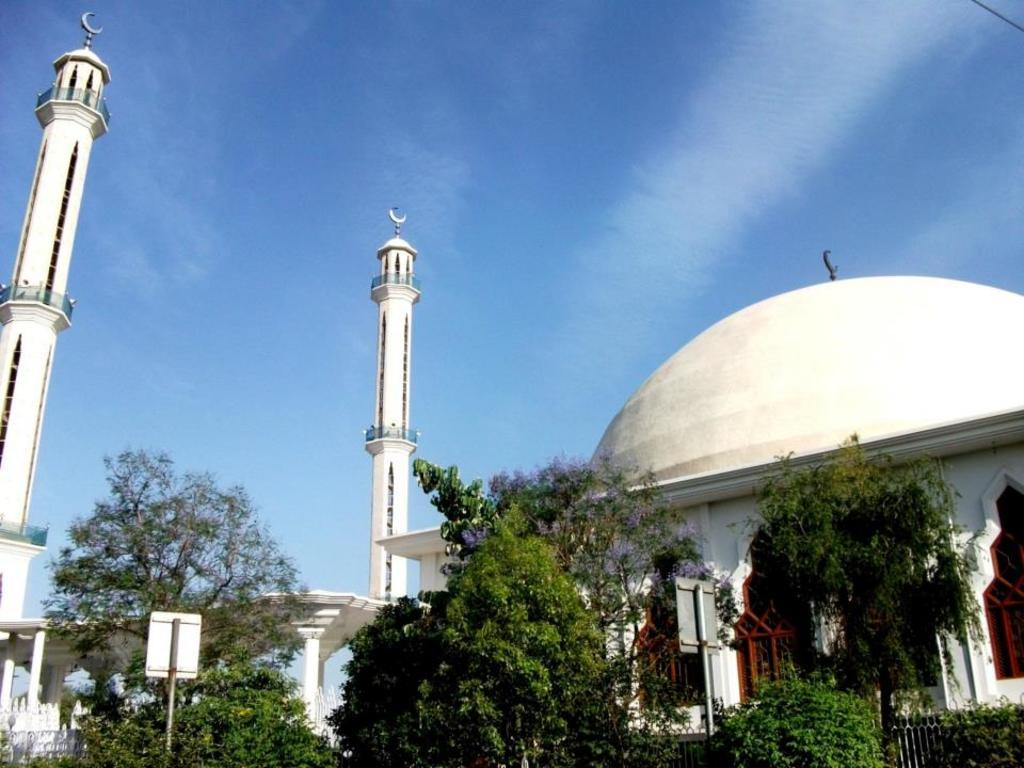What type of structure is visible in the image? There is a building with windows and towers in the image. What can be seen in the vicinity of the building? There is a group of trees and a fence in the image. Are there any additional features on the building? Yes, there are sign boards on a pole in the image. What is the condition of the sky in the image? The sky is visible in the image and appears cloudy. What type of pain is the building experiencing in the image? There is no indication of pain in the image; it is a building with windows, towers, and other features. What appliance can be seen plugged into the building in the image? There is no appliance visible in the image; it only shows the building, trees, fence, sign boards, and the sky. 